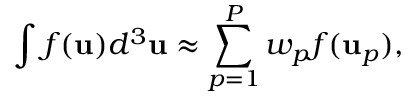<formula> <loc_0><loc_0><loc_500><loc_500>\int f ( u ) d ^ { 3 } u \approx \sum _ { p = 1 } ^ { P } w _ { p } f ( u _ { p } ) ,</formula> 